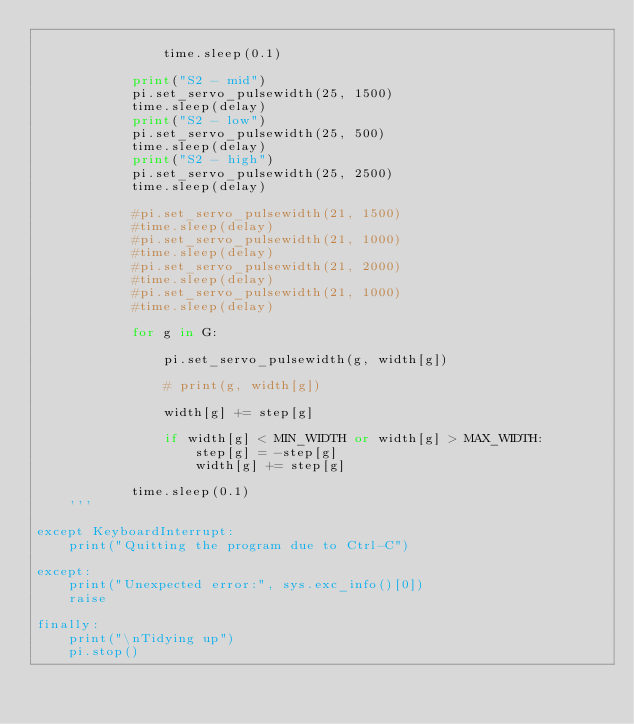<code> <loc_0><loc_0><loc_500><loc_500><_Python_>    
                time.sleep(0.1)
    
            print("S2 - mid")
            pi.set_servo_pulsewidth(25, 1500)
            time.sleep(delay)
            print("S2 - low")
            pi.set_servo_pulsewidth(25, 500)
            time.sleep(delay)
            print("S2 - high")
            pi.set_servo_pulsewidth(25, 2500)
            time.sleep(delay)
    
            #pi.set_servo_pulsewidth(21, 1500)
            #time.sleep(delay)
            #pi.set_servo_pulsewidth(21, 1000)
            #time.sleep(delay)
            #pi.set_servo_pulsewidth(21, 2000)
            #time.sleep(delay)
            #pi.set_servo_pulsewidth(21, 1000)
            #time.sleep(delay)
    
            for g in G:
    
                pi.set_servo_pulsewidth(g, width[g])
    
                # print(g, width[g])
    
                width[g] += step[g]
    
                if width[g] < MIN_WIDTH or width[g] > MAX_WIDTH:
                    step[g] = -step[g]
                    width[g] += step[g]
    
            time.sleep(0.1)
    '''

except KeyboardInterrupt:
    print("Quitting the program due to Ctrl-C")

except:
    print("Unexpected error:", sys.exc_info()[0])
    raise

finally:
    print("\nTidying up")
    pi.stop()</code> 